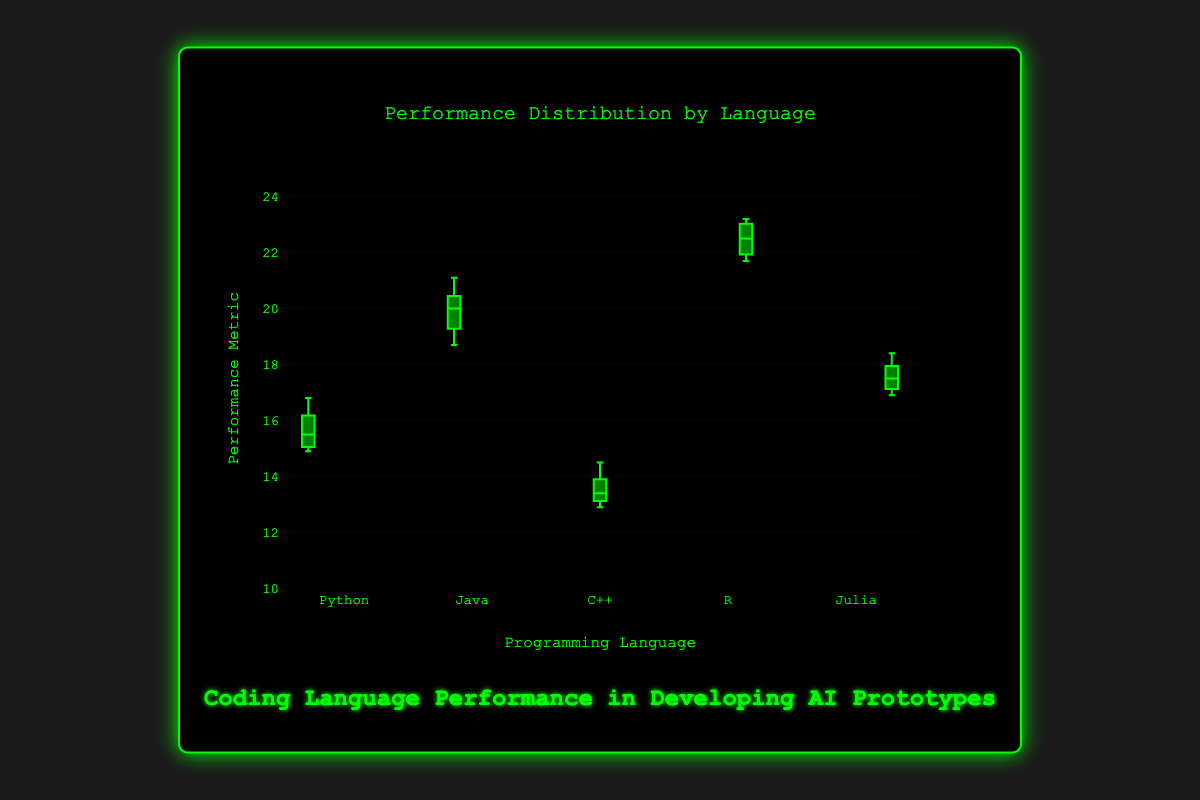What is the title of the figure? The title is displayed in the box above the plot. It says "Performance Distribution by Language".
Answer: Performance Distribution by Language What is the y-axis representing? The y-axis title is visible on the left side of the plot and it says "Performance Metric". So, it's representing the Performance Metric.
Answer: Performance Metric Which programming language shows the highest median performance? The median is the line in the middle of the box in the box plot. R has the highest median as its median line is above all others.
Answer: R Which language has the smallest interquartile range (IQR)? The IQR is the box's height; it is the range between the first quartile (bottom of the box) and the third quartile (top of the box). C++ has the smallest box, indicating the smallest IQR.
Answer: C++ What is the range of performance metrics for Julia? The range is from the minimum to the maximum values represented by the whiskers. For Julia, the whiskers extend from around 16.9 to 18.4.
Answer: 16.9 to 18.4 What is the performance metric of the median for Python? The median is the line in the middle of the box for each language. For Python, this median line is at approximately 15.5.
Answer: 15.5 How does the variability of Java's performance compare to Python's? Variability is indicated by the height of the boxes as well as the range between the whiskers (total range). Java’s box is taller and its whiskers extend wider compared to Python, indicating higher variability.
Answer: Higher Which language's highest point is lower than Java's lowest point? Comparing the whiskers, the highest point for C++ (around 14.5) is lower than Java's lowest point which is around 18.7.
Answer: C++ Between Python and Julia, which has a higher third quartile? The top of the box represents the third quartile. Julia's third quartile is at about 18.0 which is higher than Python's third quartile at about 16.2.
Answer: Julia What is the approximate first quartile value for R? The first quartile is represented by the bottom of the box. For R, this is at around 21.9.
Answer: 21.9 